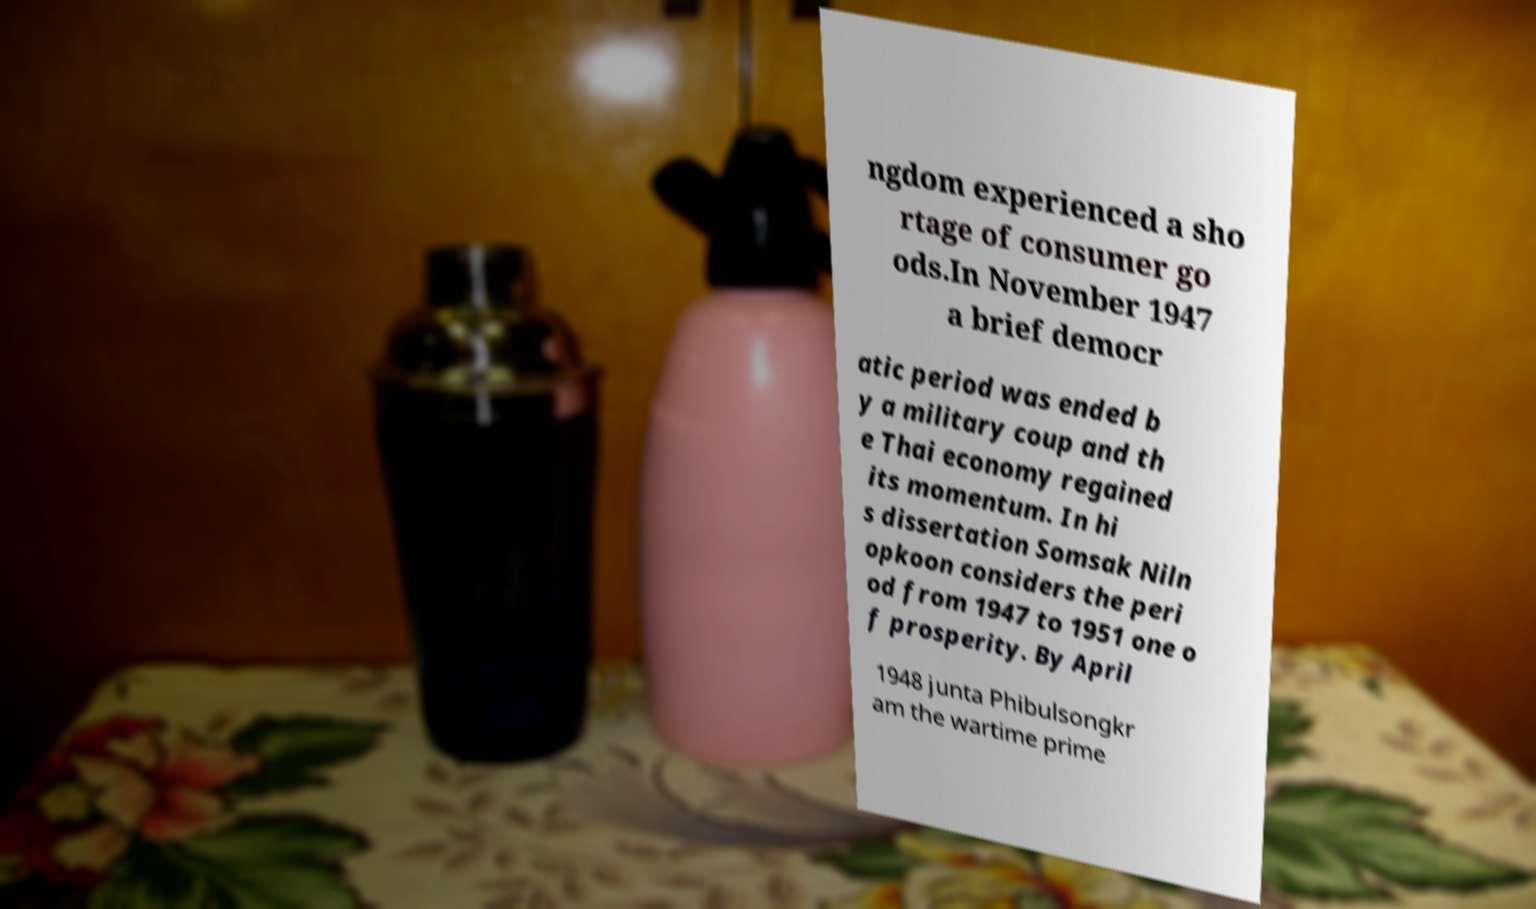What messages or text are displayed in this image? I need them in a readable, typed format. ngdom experienced a sho rtage of consumer go ods.In November 1947 a brief democr atic period was ended b y a military coup and th e Thai economy regained its momentum. In hi s dissertation Somsak Niln opkoon considers the peri od from 1947 to 1951 one o f prosperity. By April 1948 junta Phibulsongkr am the wartime prime 